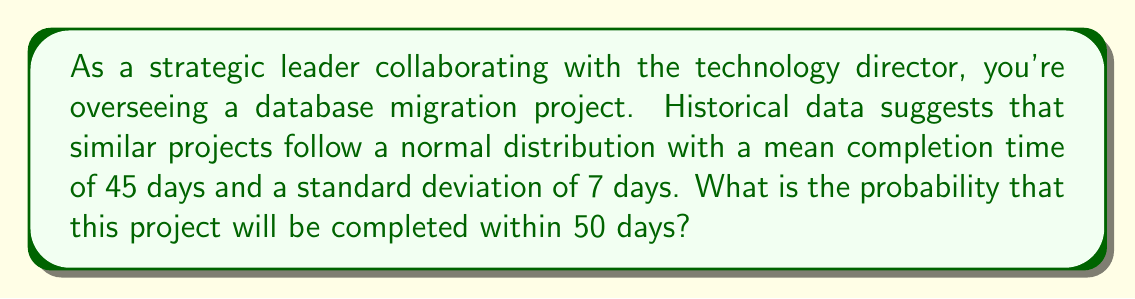Can you answer this question? To solve this problem, we'll use the standard normal distribution (z-score) approach:

1) First, calculate the z-score for 50 days:

   $z = \frac{x - \mu}{\sigma}$

   Where:
   $x$ = 50 days (the value we're interested in)
   $\mu$ = 45 days (the mean)
   $\sigma$ = 7 days (the standard deviation)

   $z = \frac{50 - 45}{7} = \frac{5}{7} \approx 0.7143$

2) Now, we need to find the probability that corresponds to this z-score. We'll use the standard normal cumulative distribution function (CDF), often denoted as $\Phi(z)$.

3) Using a standard normal table or a calculator with this function:

   $\Phi(0.7143) \approx 0.7624$

4) This means there's approximately a 76.24% chance that the project will be completed within 50 days.

5) To express this as a probability, we convert the percentage to a decimal:

   $0.7624 = 0.7624$

Therefore, the probability that the project will be completed within 50 days is approximately 0.7624 or 76.24%.
Answer: 0.7624 